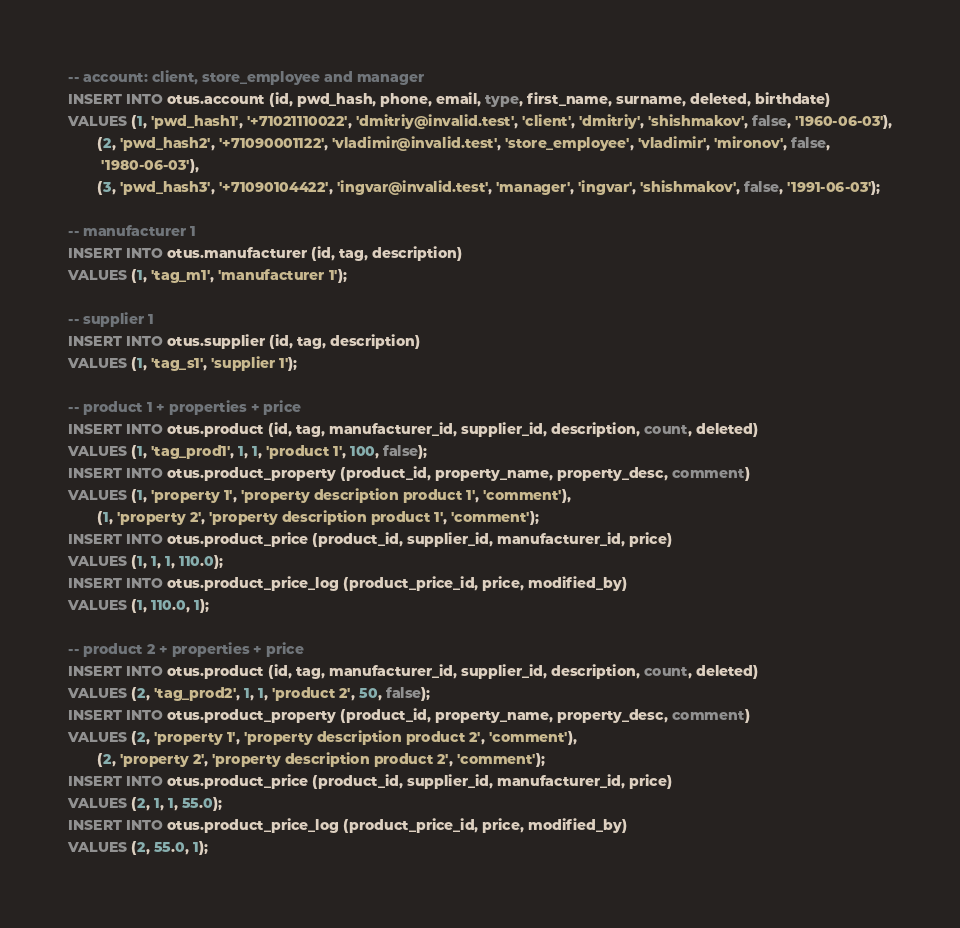<code> <loc_0><loc_0><loc_500><loc_500><_SQL_>-- account: client, store_employee and manager
INSERT INTO otus.account (id, pwd_hash, phone, email, type, first_name, surname, deleted, birthdate)
VALUES (1, 'pwd_hash1', '+71021110022', 'dmitriy@invalid.test', 'client', 'dmitriy', 'shishmakov', false, '1960-06-03'),
       (2, 'pwd_hash2', '+71090001122', 'vladimir@invalid.test', 'store_employee', 'vladimir', 'mironov', false,
        '1980-06-03'),
       (3, 'pwd_hash3', '+71090104422', 'ingvar@invalid.test', 'manager', 'ingvar', 'shishmakov', false, '1991-06-03');

-- manufacturer 1
INSERT INTO otus.manufacturer (id, tag, description)
VALUES (1, 'tag_m1', 'manufacturer 1');

-- supplier 1
INSERT INTO otus.supplier (id, tag, description)
VALUES (1, 'tag_s1', 'supplier 1');

-- product 1 + properties + price
INSERT INTO otus.product (id, tag, manufacturer_id, supplier_id, description, count, deleted)
VALUES (1, 'tag_prod1', 1, 1, 'product 1', 100, false);
INSERT INTO otus.product_property (product_id, property_name, property_desc, comment)
VALUES (1, 'property 1', 'property description product 1', 'comment'),
       (1, 'property 2', 'property description product 1', 'comment');
INSERT INTO otus.product_price (product_id, supplier_id, manufacturer_id, price)
VALUES (1, 1, 1, 110.0);
INSERT INTO otus.product_price_log (product_price_id, price, modified_by)
VALUES (1, 110.0, 1);

-- product 2 + properties + price
INSERT INTO otus.product (id, tag, manufacturer_id, supplier_id, description, count, deleted)
VALUES (2, 'tag_prod2', 1, 1, 'product 2', 50, false);
INSERT INTO otus.product_property (product_id, property_name, property_desc, comment)
VALUES (2, 'property 1', 'property description product 2', 'comment'),
       (2, 'property 2', 'property description product 2', 'comment');
INSERT INTO otus.product_price (product_id, supplier_id, manufacturer_id, price)
VALUES (2, 1, 1, 55.0);
INSERT INTO otus.product_price_log (product_price_id, price, modified_by)
VALUES (2, 55.0, 1);
</code> 